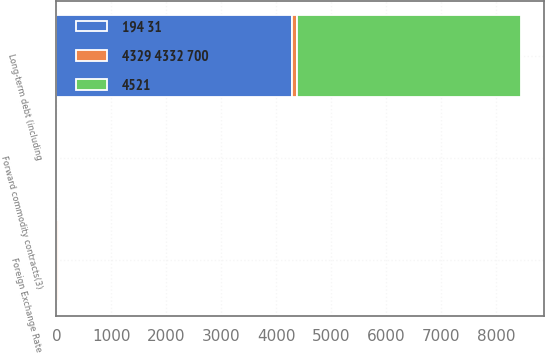Convert chart to OTSL. <chart><loc_0><loc_0><loc_500><loc_500><stacked_bar_chart><ecel><fcel>Forward commodity contracts(3)<fcel>Long-term debt (including<fcel>Foreign Exchange Rate<nl><fcel>4521<fcel>9<fcel>4077<fcel>2<nl><fcel>194 31<fcel>9<fcel>4291<fcel>2<nl><fcel>4329 4332 700<fcel>10<fcel>88<fcel>36<nl></chart> 